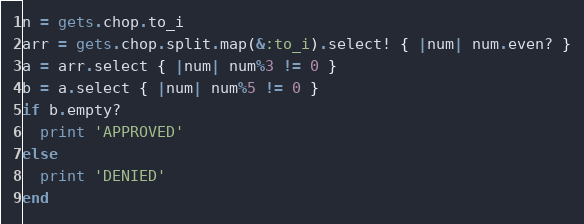<code> <loc_0><loc_0><loc_500><loc_500><_Ruby_>n = gets.chop.to_i
arr = gets.chop.split.map(&:to_i).select! { |num| num.even? }
a = arr.select { |num| num%3 != 0 }
b = a.select { |num| num%5 != 0 }
if b.empty?
  print 'APPROVED'
else
  print 'DENIED'
end</code> 